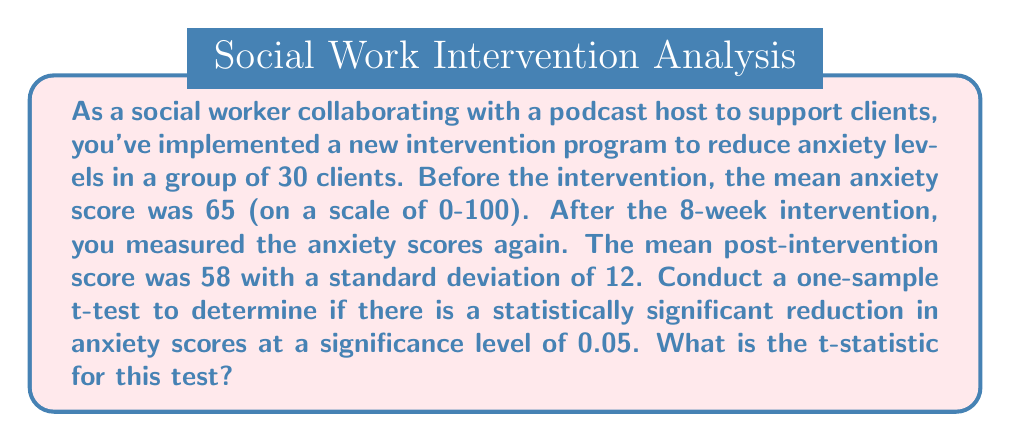Can you solve this math problem? To conduct a one-sample t-test and calculate the t-statistic, we'll follow these steps:

1. Define the null and alternative hypotheses:
   $H_0: \mu = 65$ (no change in anxiety scores)
   $H_1: \mu < 65$ (anxiety scores decreased)

2. Calculate the t-statistic using the formula:
   $$t = \frac{\bar{x} - \mu_0}{s / \sqrt{n}}$$
   
   Where:
   $\bar{x}$ = sample mean (post-intervention score) = 58
   $\mu_0$ = hypothesized population mean (pre-intervention score) = 65
   $s$ = sample standard deviation = 12
   $n$ = sample size = 30

3. Plug in the values:
   $$t = \frac{58 - 65}{12 / \sqrt{30}}$$

4. Simplify:
   $$t = \frac{-7}{12 / \sqrt{30}} = \frac{-7}{12 / 5.477} = \frac{-7}{2.192} = -3.194$$

The calculated t-statistic is -3.194. This negative value indicates that the sample mean is lower than the hypothesized population mean, which aligns with our alternative hypothesis of decreased anxiety scores.
Answer: The t-statistic for this one-sample t-test is $-3.194$. 